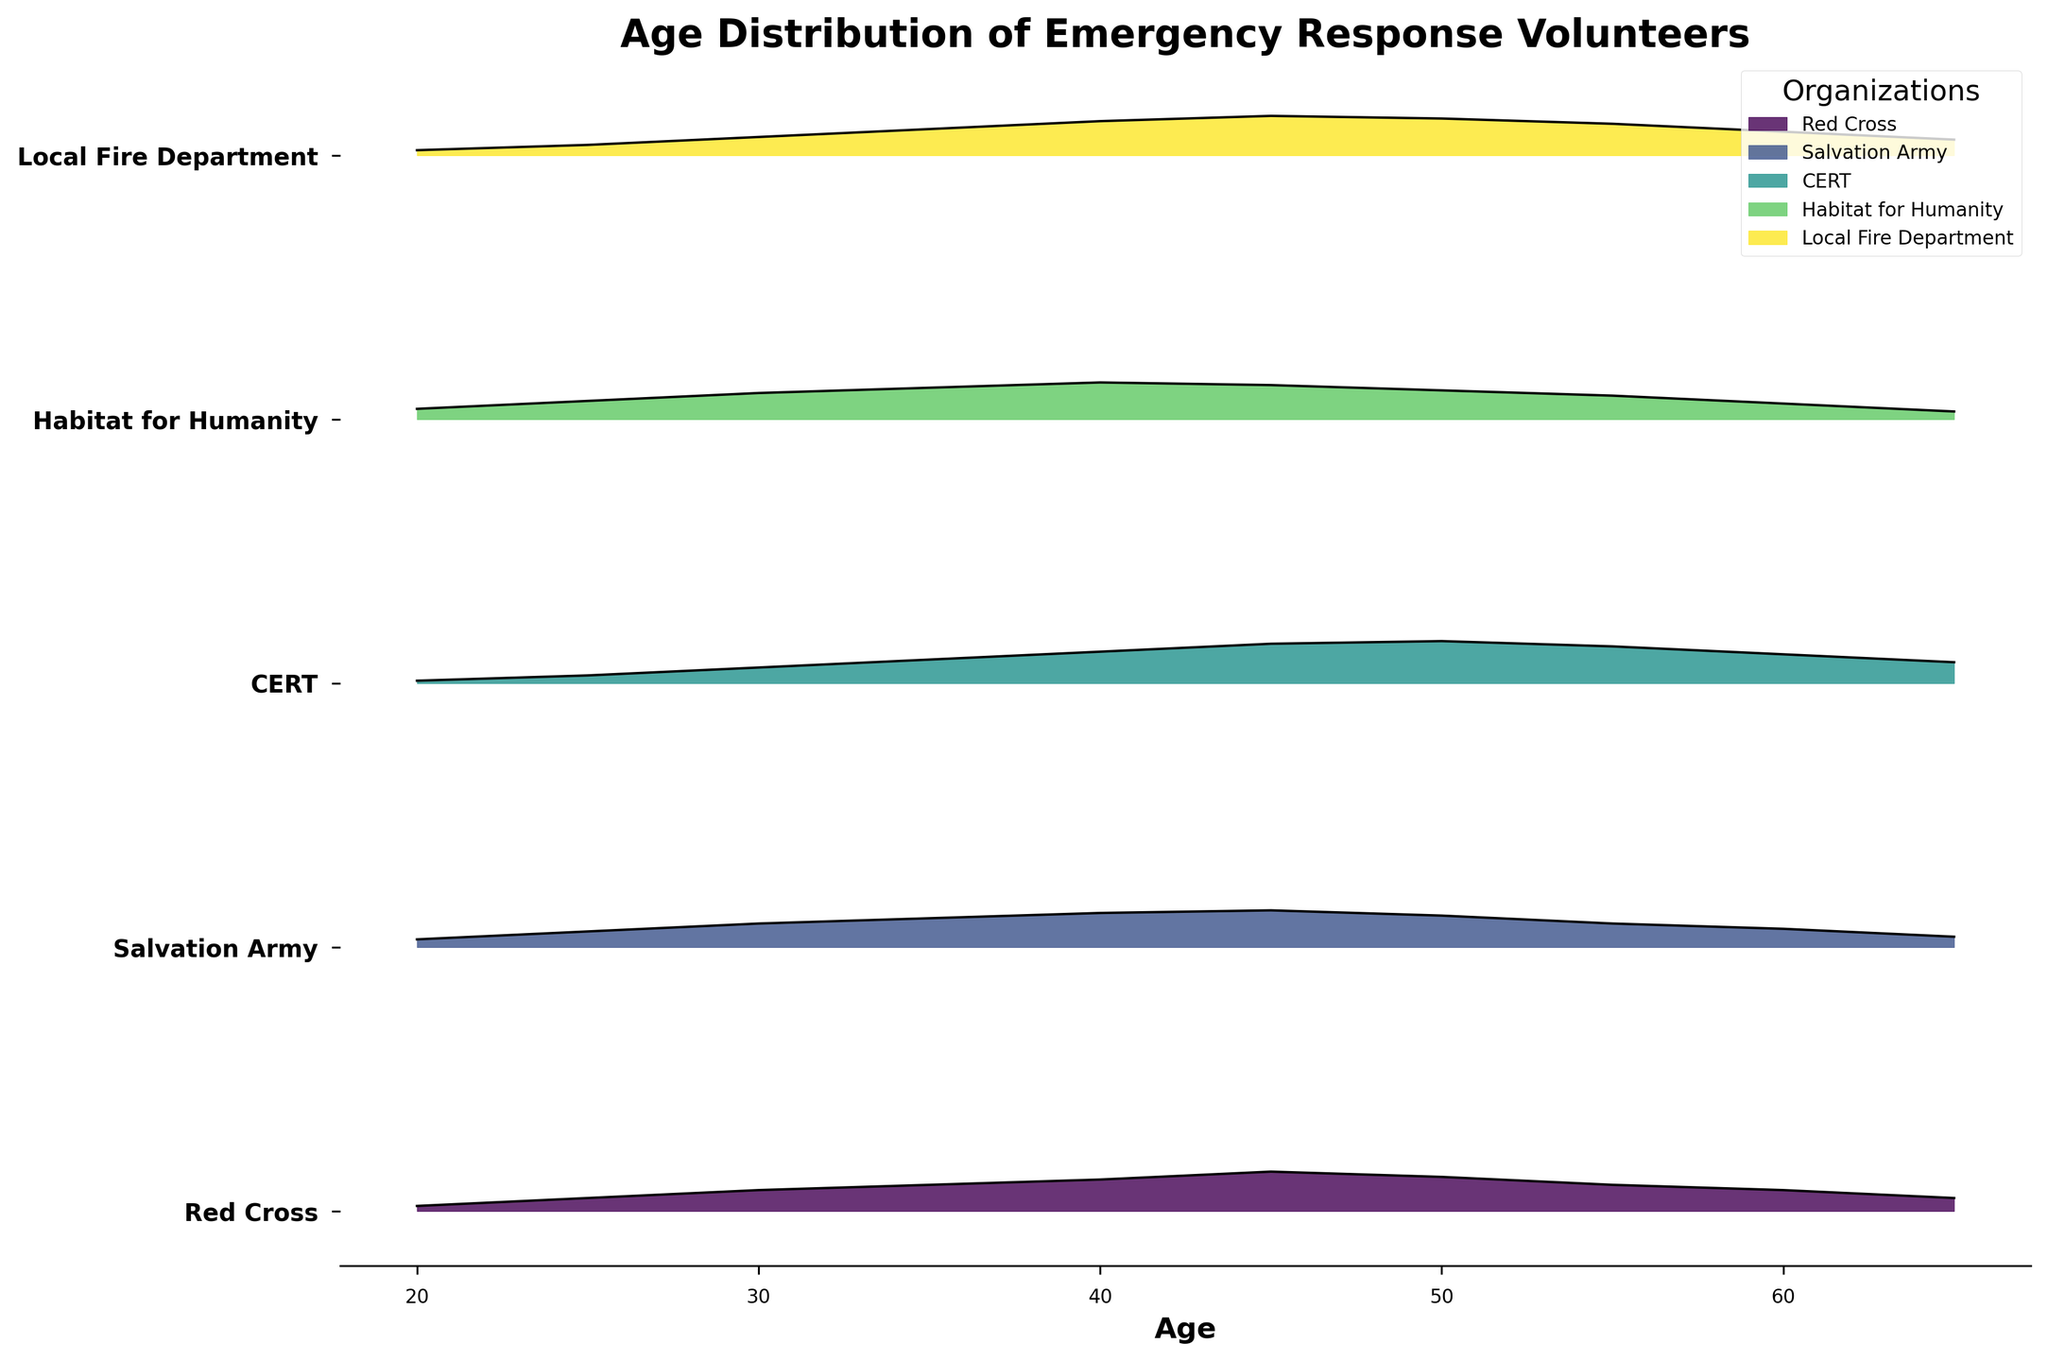What is the title of the figure? The title is usually located at the top of the figure and is the largest text in bold. It provides an overview of what the figure is about. In this case, it clearly states "Age Distribution of Emergency Response Volunteers".
Answer: Age Distribution of Emergency Response Volunteers How many organizations are represented in the plot? The y-axis of the plot lists the names of the organizations. By counting these names along the axis, we can determine the number of unique organizations displayed.
Answer: 5 Which organization has its age distribution peak at the highest age? By examining the ridgeline plot, the peaks of the distributions for each organization can be identified. CERT's distribution peaks at age 50.
Answer: CERT At what age does the "Local Fire Department" have its highest density of volunteers? Look at the ridgeline corresponding to "Local Fire Department" and identify the age at which the density is the highest. The highest density point appears at age 45.
Answer: 45 Compare the peak density values between "Salvation Army" and "Red Cross". Which one is higher and by how much? First, identify the peak density values for both organizations from the plot. "Salvation Army" peaks at 0.14 and "Red Cross" peaks at 0.15. Subtract the smaller value from the larger to get the difference.
Answer: Red Cross has a higher peak by 0.01 What is the range of ages covered in the plot for all organizations? The x-axis represents age. Observe the minimum and maximum age values shown in the plot. All organizations have data ranging from age 20 to 65.
Answer: 20 to 65 Which organization has the most pronounced peak in their age distribution and how can you tell? The height and sharpness of the peaks indicate how pronounced they are. "CERT" has the most pronounced peak, as its density reaches higher values more sharply compared to others.
Answer: CERT What trend can be observed in the age distribution of volunteers for "Habitat for Humanity"? Observe the shape of the ridgeline plot for "Habitat for Humanity". The trend shows a gentle increase in density up to age 40, followed by a gradual decrease.
Answer: Increases to 40, then decreases How does the age distribution of "Salvation Army" compare to "Habitat for Humanity"? Compare the shapes and peaks of both ridgelines. "Salvation Army" peaks at age 45 with a higher density, whereas "Habitat for Humanity" peaks at age 40 with a slightly lower density.
Answer: Salvation Army peaks at a higher age with a higher peak density Which age is least represented across all organizations? Find the age with the lowest density across all ridgelines. Ages 20 and 65 consistently show lower densities across organizations.
Answer: 20 and 65 